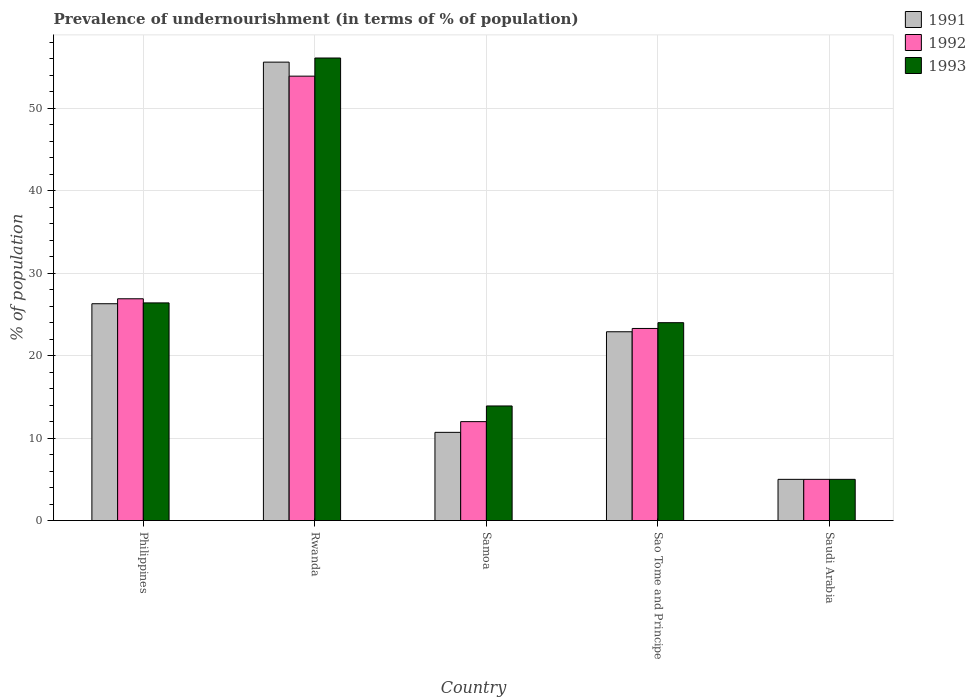How many groups of bars are there?
Your answer should be very brief. 5. How many bars are there on the 1st tick from the left?
Offer a terse response. 3. How many bars are there on the 5th tick from the right?
Your response must be concise. 3. What is the label of the 5th group of bars from the left?
Provide a succinct answer. Saudi Arabia. What is the percentage of undernourished population in 1992 in Philippines?
Offer a very short reply. 26.9. Across all countries, what is the maximum percentage of undernourished population in 1991?
Offer a terse response. 55.6. In which country was the percentage of undernourished population in 1991 maximum?
Your answer should be very brief. Rwanda. In which country was the percentage of undernourished population in 1992 minimum?
Provide a short and direct response. Saudi Arabia. What is the total percentage of undernourished population in 1993 in the graph?
Give a very brief answer. 125.4. What is the average percentage of undernourished population in 1991 per country?
Ensure brevity in your answer.  24.1. What is the difference between the percentage of undernourished population of/in 1993 and percentage of undernourished population of/in 1991 in Philippines?
Offer a terse response. 0.1. In how many countries, is the percentage of undernourished population in 1991 greater than 52 %?
Give a very brief answer. 1. What is the ratio of the percentage of undernourished population in 1993 in Samoa to that in Sao Tome and Principe?
Provide a short and direct response. 0.58. What is the difference between the highest and the lowest percentage of undernourished population in 1993?
Keep it short and to the point. 51.1. In how many countries, is the percentage of undernourished population in 1993 greater than the average percentage of undernourished population in 1993 taken over all countries?
Give a very brief answer. 2. Is the sum of the percentage of undernourished population in 1991 in Rwanda and Sao Tome and Principe greater than the maximum percentage of undernourished population in 1992 across all countries?
Make the answer very short. Yes. What does the 3rd bar from the left in Sao Tome and Principe represents?
Offer a terse response. 1993. What does the 1st bar from the right in Samoa represents?
Provide a succinct answer. 1993. Are all the bars in the graph horizontal?
Give a very brief answer. No. How many countries are there in the graph?
Provide a short and direct response. 5. What is the difference between two consecutive major ticks on the Y-axis?
Ensure brevity in your answer.  10. How many legend labels are there?
Ensure brevity in your answer.  3. What is the title of the graph?
Make the answer very short. Prevalence of undernourishment (in terms of % of population). What is the label or title of the Y-axis?
Offer a very short reply. % of population. What is the % of population of 1991 in Philippines?
Give a very brief answer. 26.3. What is the % of population in 1992 in Philippines?
Make the answer very short. 26.9. What is the % of population of 1993 in Philippines?
Your answer should be very brief. 26.4. What is the % of population of 1991 in Rwanda?
Give a very brief answer. 55.6. What is the % of population of 1992 in Rwanda?
Your answer should be very brief. 53.9. What is the % of population of 1993 in Rwanda?
Your answer should be compact. 56.1. What is the % of population of 1991 in Samoa?
Your answer should be compact. 10.7. What is the % of population in 1992 in Samoa?
Ensure brevity in your answer.  12. What is the % of population of 1991 in Sao Tome and Principe?
Offer a very short reply. 22.9. What is the % of population in 1992 in Sao Tome and Principe?
Your answer should be compact. 23.3. Across all countries, what is the maximum % of population in 1991?
Provide a short and direct response. 55.6. Across all countries, what is the maximum % of population in 1992?
Keep it short and to the point. 53.9. Across all countries, what is the maximum % of population in 1993?
Give a very brief answer. 56.1. What is the total % of population in 1991 in the graph?
Offer a very short reply. 120.5. What is the total % of population in 1992 in the graph?
Provide a succinct answer. 121.1. What is the total % of population in 1993 in the graph?
Your answer should be compact. 125.4. What is the difference between the % of population of 1991 in Philippines and that in Rwanda?
Provide a short and direct response. -29.3. What is the difference between the % of population in 1993 in Philippines and that in Rwanda?
Ensure brevity in your answer.  -29.7. What is the difference between the % of population of 1991 in Philippines and that in Sao Tome and Principe?
Give a very brief answer. 3.4. What is the difference between the % of population in 1992 in Philippines and that in Sao Tome and Principe?
Offer a terse response. 3.6. What is the difference between the % of population in 1993 in Philippines and that in Sao Tome and Principe?
Give a very brief answer. 2.4. What is the difference between the % of population in 1991 in Philippines and that in Saudi Arabia?
Give a very brief answer. 21.3. What is the difference between the % of population in 1992 in Philippines and that in Saudi Arabia?
Ensure brevity in your answer.  21.9. What is the difference between the % of population of 1993 in Philippines and that in Saudi Arabia?
Your response must be concise. 21.4. What is the difference between the % of population in 1991 in Rwanda and that in Samoa?
Your response must be concise. 44.9. What is the difference between the % of population in 1992 in Rwanda and that in Samoa?
Provide a succinct answer. 41.9. What is the difference between the % of population in 1993 in Rwanda and that in Samoa?
Keep it short and to the point. 42.2. What is the difference between the % of population of 1991 in Rwanda and that in Sao Tome and Principe?
Keep it short and to the point. 32.7. What is the difference between the % of population in 1992 in Rwanda and that in Sao Tome and Principe?
Your response must be concise. 30.6. What is the difference between the % of population in 1993 in Rwanda and that in Sao Tome and Principe?
Keep it short and to the point. 32.1. What is the difference between the % of population of 1991 in Rwanda and that in Saudi Arabia?
Your response must be concise. 50.6. What is the difference between the % of population in 1992 in Rwanda and that in Saudi Arabia?
Keep it short and to the point. 48.9. What is the difference between the % of population of 1993 in Rwanda and that in Saudi Arabia?
Provide a short and direct response. 51.1. What is the difference between the % of population in 1992 in Samoa and that in Sao Tome and Principe?
Your answer should be very brief. -11.3. What is the difference between the % of population in 1991 in Sao Tome and Principe and that in Saudi Arabia?
Your answer should be compact. 17.9. What is the difference between the % of population in 1993 in Sao Tome and Principe and that in Saudi Arabia?
Make the answer very short. 19. What is the difference between the % of population in 1991 in Philippines and the % of population in 1992 in Rwanda?
Your answer should be very brief. -27.6. What is the difference between the % of population of 1991 in Philippines and the % of population of 1993 in Rwanda?
Offer a very short reply. -29.8. What is the difference between the % of population of 1992 in Philippines and the % of population of 1993 in Rwanda?
Your answer should be compact. -29.2. What is the difference between the % of population in 1991 in Philippines and the % of population in 1992 in Saudi Arabia?
Provide a succinct answer. 21.3. What is the difference between the % of population in 1991 in Philippines and the % of population in 1993 in Saudi Arabia?
Your answer should be very brief. 21.3. What is the difference between the % of population in 1992 in Philippines and the % of population in 1993 in Saudi Arabia?
Give a very brief answer. 21.9. What is the difference between the % of population in 1991 in Rwanda and the % of population in 1992 in Samoa?
Offer a terse response. 43.6. What is the difference between the % of population in 1991 in Rwanda and the % of population in 1993 in Samoa?
Ensure brevity in your answer.  41.7. What is the difference between the % of population of 1992 in Rwanda and the % of population of 1993 in Samoa?
Your response must be concise. 40. What is the difference between the % of population of 1991 in Rwanda and the % of population of 1992 in Sao Tome and Principe?
Give a very brief answer. 32.3. What is the difference between the % of population of 1991 in Rwanda and the % of population of 1993 in Sao Tome and Principe?
Keep it short and to the point. 31.6. What is the difference between the % of population in 1992 in Rwanda and the % of population in 1993 in Sao Tome and Principe?
Your response must be concise. 29.9. What is the difference between the % of population in 1991 in Rwanda and the % of population in 1992 in Saudi Arabia?
Offer a terse response. 50.6. What is the difference between the % of population in 1991 in Rwanda and the % of population in 1993 in Saudi Arabia?
Keep it short and to the point. 50.6. What is the difference between the % of population in 1992 in Rwanda and the % of population in 1993 in Saudi Arabia?
Offer a terse response. 48.9. What is the difference between the % of population of 1991 in Samoa and the % of population of 1992 in Sao Tome and Principe?
Your answer should be very brief. -12.6. What is the difference between the % of population in 1991 in Samoa and the % of population in 1993 in Sao Tome and Principe?
Your response must be concise. -13.3. What is the difference between the % of population of 1991 in Samoa and the % of population of 1992 in Saudi Arabia?
Your response must be concise. 5.7. What is the difference between the % of population of 1991 in Samoa and the % of population of 1993 in Saudi Arabia?
Offer a very short reply. 5.7. What is the difference between the % of population in 1992 in Samoa and the % of population in 1993 in Saudi Arabia?
Make the answer very short. 7. What is the difference between the % of population of 1991 in Sao Tome and Principe and the % of population of 1993 in Saudi Arabia?
Your response must be concise. 17.9. What is the average % of population in 1991 per country?
Make the answer very short. 24.1. What is the average % of population of 1992 per country?
Your response must be concise. 24.22. What is the average % of population in 1993 per country?
Provide a succinct answer. 25.08. What is the difference between the % of population of 1991 and % of population of 1992 in Philippines?
Ensure brevity in your answer.  -0.6. What is the difference between the % of population of 1991 and % of population of 1993 in Philippines?
Offer a very short reply. -0.1. What is the difference between the % of population of 1992 and % of population of 1993 in Philippines?
Your answer should be compact. 0.5. What is the difference between the % of population of 1991 and % of population of 1992 in Rwanda?
Make the answer very short. 1.7. What is the difference between the % of population of 1992 and % of population of 1993 in Rwanda?
Your response must be concise. -2.2. What is the difference between the % of population in 1991 and % of population in 1993 in Samoa?
Give a very brief answer. -3.2. What is the difference between the % of population of 1992 and % of population of 1993 in Samoa?
Your response must be concise. -1.9. What is the difference between the % of population in 1991 and % of population in 1992 in Sao Tome and Principe?
Give a very brief answer. -0.4. What is the difference between the % of population in 1991 and % of population in 1993 in Sao Tome and Principe?
Provide a succinct answer. -1.1. What is the difference between the % of population in 1991 and % of population in 1993 in Saudi Arabia?
Make the answer very short. 0. What is the difference between the % of population of 1992 and % of population of 1993 in Saudi Arabia?
Offer a very short reply. 0. What is the ratio of the % of population of 1991 in Philippines to that in Rwanda?
Your response must be concise. 0.47. What is the ratio of the % of population of 1992 in Philippines to that in Rwanda?
Make the answer very short. 0.5. What is the ratio of the % of population in 1993 in Philippines to that in Rwanda?
Provide a short and direct response. 0.47. What is the ratio of the % of population in 1991 in Philippines to that in Samoa?
Provide a short and direct response. 2.46. What is the ratio of the % of population in 1992 in Philippines to that in Samoa?
Provide a short and direct response. 2.24. What is the ratio of the % of population in 1993 in Philippines to that in Samoa?
Your answer should be very brief. 1.9. What is the ratio of the % of population in 1991 in Philippines to that in Sao Tome and Principe?
Provide a short and direct response. 1.15. What is the ratio of the % of population of 1992 in Philippines to that in Sao Tome and Principe?
Provide a succinct answer. 1.15. What is the ratio of the % of population in 1991 in Philippines to that in Saudi Arabia?
Give a very brief answer. 5.26. What is the ratio of the % of population in 1992 in Philippines to that in Saudi Arabia?
Provide a short and direct response. 5.38. What is the ratio of the % of population of 1993 in Philippines to that in Saudi Arabia?
Provide a succinct answer. 5.28. What is the ratio of the % of population in 1991 in Rwanda to that in Samoa?
Your answer should be very brief. 5.2. What is the ratio of the % of population in 1992 in Rwanda to that in Samoa?
Offer a terse response. 4.49. What is the ratio of the % of population in 1993 in Rwanda to that in Samoa?
Provide a short and direct response. 4.04. What is the ratio of the % of population in 1991 in Rwanda to that in Sao Tome and Principe?
Make the answer very short. 2.43. What is the ratio of the % of population in 1992 in Rwanda to that in Sao Tome and Principe?
Your answer should be very brief. 2.31. What is the ratio of the % of population in 1993 in Rwanda to that in Sao Tome and Principe?
Your response must be concise. 2.34. What is the ratio of the % of population of 1991 in Rwanda to that in Saudi Arabia?
Give a very brief answer. 11.12. What is the ratio of the % of population in 1992 in Rwanda to that in Saudi Arabia?
Make the answer very short. 10.78. What is the ratio of the % of population of 1993 in Rwanda to that in Saudi Arabia?
Your answer should be compact. 11.22. What is the ratio of the % of population of 1991 in Samoa to that in Sao Tome and Principe?
Provide a succinct answer. 0.47. What is the ratio of the % of population of 1992 in Samoa to that in Sao Tome and Principe?
Your answer should be compact. 0.52. What is the ratio of the % of population in 1993 in Samoa to that in Sao Tome and Principe?
Provide a succinct answer. 0.58. What is the ratio of the % of population in 1991 in Samoa to that in Saudi Arabia?
Give a very brief answer. 2.14. What is the ratio of the % of population of 1992 in Samoa to that in Saudi Arabia?
Offer a very short reply. 2.4. What is the ratio of the % of population in 1993 in Samoa to that in Saudi Arabia?
Your answer should be compact. 2.78. What is the ratio of the % of population of 1991 in Sao Tome and Principe to that in Saudi Arabia?
Your response must be concise. 4.58. What is the ratio of the % of population in 1992 in Sao Tome and Principe to that in Saudi Arabia?
Keep it short and to the point. 4.66. What is the ratio of the % of population of 1993 in Sao Tome and Principe to that in Saudi Arabia?
Provide a short and direct response. 4.8. What is the difference between the highest and the second highest % of population of 1991?
Your answer should be very brief. 29.3. What is the difference between the highest and the second highest % of population in 1992?
Keep it short and to the point. 27. What is the difference between the highest and the second highest % of population of 1993?
Your response must be concise. 29.7. What is the difference between the highest and the lowest % of population in 1991?
Your answer should be very brief. 50.6. What is the difference between the highest and the lowest % of population of 1992?
Make the answer very short. 48.9. What is the difference between the highest and the lowest % of population of 1993?
Give a very brief answer. 51.1. 